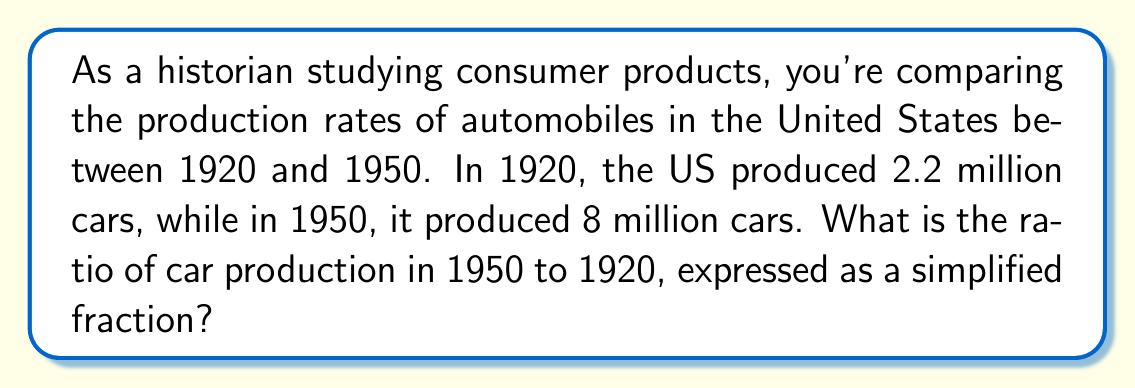Show me your answer to this math problem. To solve this problem, we need to create a ratio comparing the car production in 1950 to 1920. Let's approach this step-by-step:

1) First, let's identify our values:
   - 1920 production: 2.2 million cars
   - 1950 production: 8 million cars

2) The ratio we want is 1950 production : 1920 production

3) We can express this as a fraction:

   $$\frac{1950\text{ production}}{1920\text{ production}} = \frac{8\text{ million}}{2.2\text{ million}}$$

4) To simplify this fraction, we can divide both the numerator and denominator by 2.2 million:

   $$\frac{8\text{ million}}{2.2\text{ million}} = \frac{8 \div 2.2}{2.2 \div 2.2} = \frac{3.636...}{1}$$

5) Since we're asked for a simplified fraction, we need to convert 3.636... to a fraction. This repeating decimal can be expressed as $\frac{40}{11}$.

Therefore, the simplified ratio of car production in 1950 to 1920 is $\frac{40}{11}$.
Answer: $\frac{40}{11}$ 